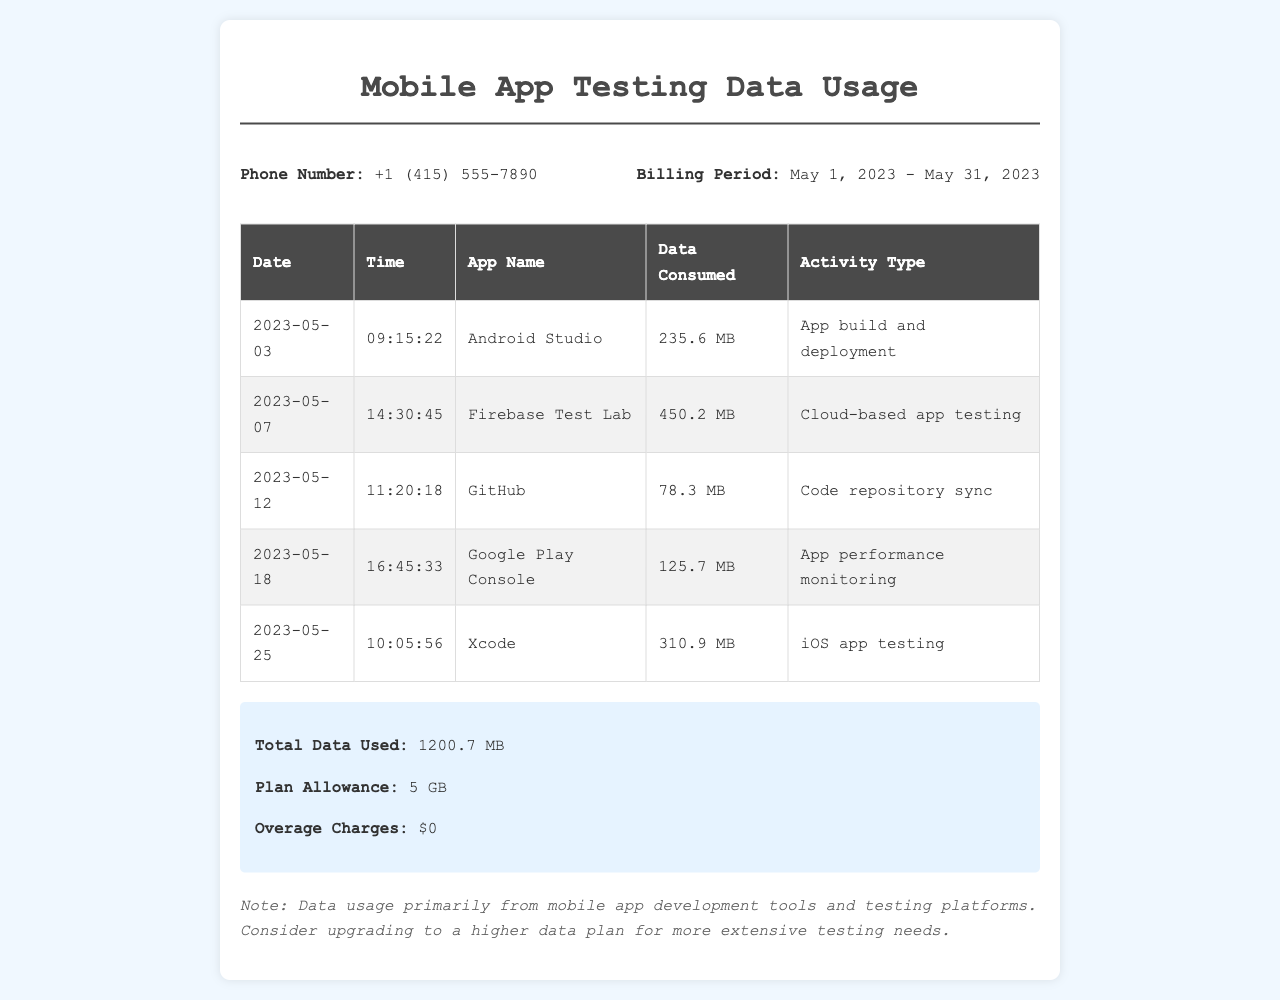what is the phone number? The phone number is listed in the document under the info section.
Answer: +1 (415) 555-7890 what is the total data used? The total data used is specified in the summary section at the bottom of the document.
Answer: 1200.7 MB which app consumed the most data? The app consuming the most data can be determined from the table by comparing the data consumed values.
Answer: Xcode on what date was the highest data usage recorded? The highest data usage can be found by looking for the largest value in the data consumed column.
Answer: 2023-05-25 what type of activity is associated with Firebase Test Lab? The activity type linked to Firebase Test Lab is described in the respective row of the table.
Answer: Cloud-based app testing how many apps are listed in the document? The number of apps can be counted from the entries in the table.
Answer: 5 what is the plan allowance? The plan allowance is noted in the summary section of the document.
Answer: 5 GB is there any overage charge? The overage charges are shown in the summary section and indicate whether any charges apply.
Answer: $0 what was the data consumption for Google Play Console? The data consumption for Google Play Console can be found in the corresponding row of the table.
Answer: 125.7 MB 